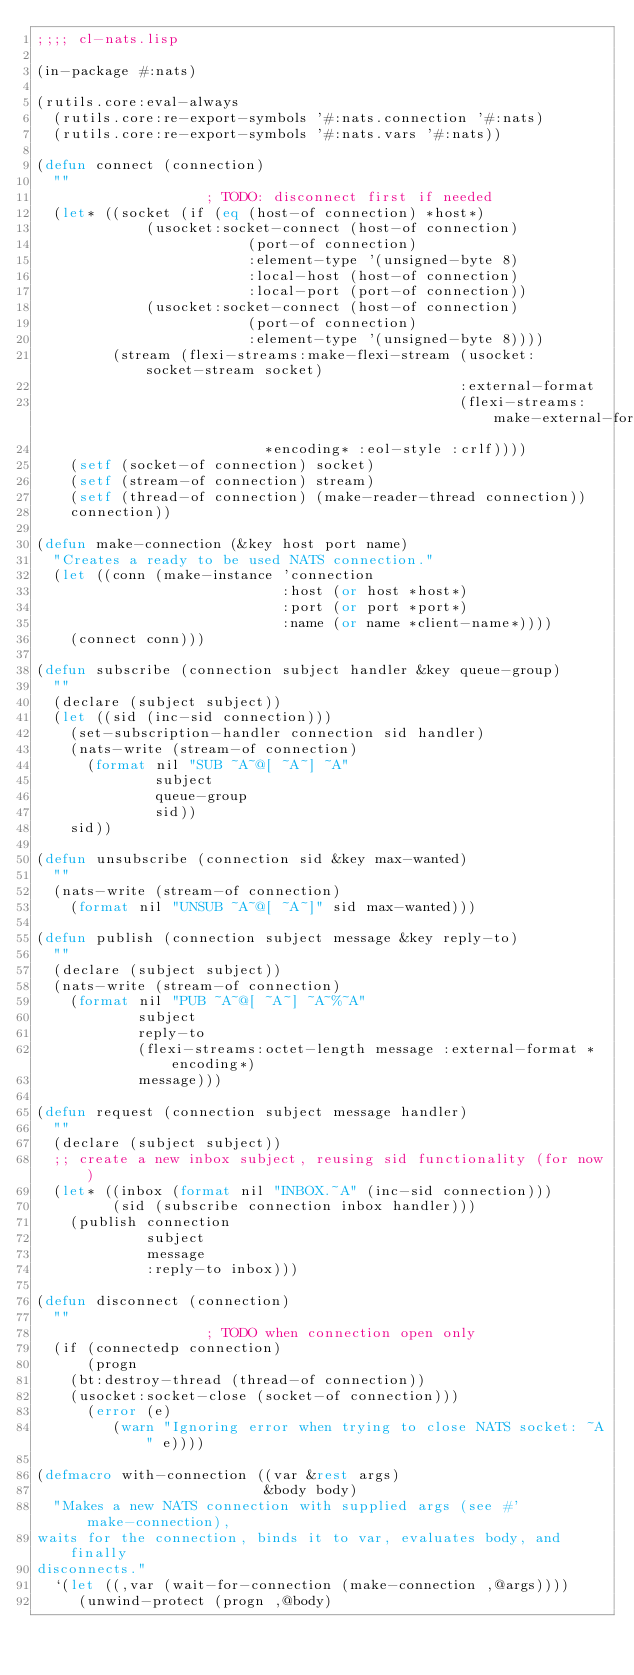Convert code to text. <code><loc_0><loc_0><loc_500><loc_500><_Lisp_>;;;; cl-nats.lisp

(in-package #:nats)

(rutils.core:eval-always
  (rutils.core:re-export-symbols '#:nats.connection '#:nats)
  (rutils.core:re-export-symbols '#:nats.vars '#:nats))

(defun connect (connection)
  ""
					; TODO: disconnect first if needed
  (let* ((socket (if (eq (host-of connection) *host*)
		     (usocket:socket-connect (host-of connection)
					     (port-of connection)
					     :element-type '(unsigned-byte 8)
					     :local-host (host-of connection)
					     :local-port (port-of connection))
		     (usocket:socket-connect (host-of connection)
					     (port-of connection)
					     :element-type '(unsigned-byte 8))))
         (stream (flexi-streams:make-flexi-stream (usocket:socket-stream socket)
                                                  :external-format
                                                  (flexi-streams:make-external-format
						   *encoding* :eol-style :crlf))))
    (setf (socket-of connection) socket)
    (setf (stream-of connection) stream)
    (setf (thread-of connection) (make-reader-thread connection))
    connection))

(defun make-connection (&key host port name)
  "Creates a ready to be used NATS connection."
  (let ((conn (make-instance 'connection
                             :host (or host *host*)
                             :port (or port *port*)
                             :name (or name *client-name*))))
    (connect conn)))

(defun subscribe (connection subject handler &key queue-group)
  ""
  (declare (subject subject))
  (let ((sid (inc-sid connection)))
    (set-subscription-handler connection sid handler)
    (nats-write (stream-of connection)
      (format nil "SUB ~A~@[ ~A~] ~A"
              subject
              queue-group
              sid))
    sid))

(defun unsubscribe (connection sid &key max-wanted)
  ""
  (nats-write (stream-of connection)
    (format nil "UNSUB ~A~@[ ~A~]" sid max-wanted)))

(defun publish (connection subject message &key reply-to)
  ""
  (declare (subject subject))
  (nats-write (stream-of connection)
    (format nil "PUB ~A~@[ ~A~] ~A~%~A"
            subject
            reply-to
            (flexi-streams:octet-length message :external-format *encoding*)
            message)))

(defun request (connection subject message handler)
  ""
  (declare (subject subject))
  ;; create a new inbox subject, reusing sid functionality (for now)
  (let* ((inbox (format nil "INBOX.~A" (inc-sid connection)))
         (sid (subscribe connection inbox handler)))
    (publish connection
             subject
             message
             :reply-to inbox)))

(defun disconnect (connection)
  ""
					; TODO when connection open only
  (if (connectedp connection)
      (progn
	(bt:destroy-thread (thread-of connection))
	(usocket:socket-close (socket-of connection)))
      (error (e)
	     (warn "Ignoring error when trying to close NATS socket: ~A" e))))

(defmacro with-connection ((var &rest args)
                           &body body)
  "Makes a new NATS connection with supplied args (see #'make-connection),
waits for the connection, binds it to var, evaluates body, and finally
disconnects."
  `(let ((,var (wait-for-connection (make-connection ,@args))))
     (unwind-protect (progn ,@body)</code> 